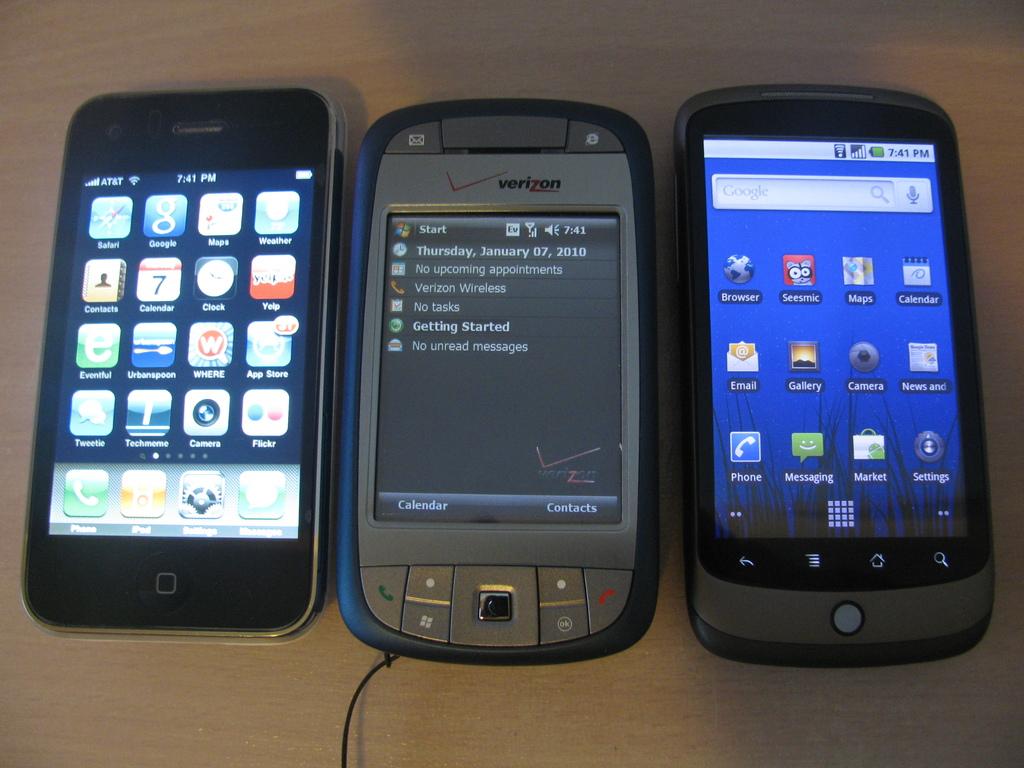What year is it?
Offer a very short reply. 2010. What is the brand on the middle phone?
Your response must be concise. Verizon. 